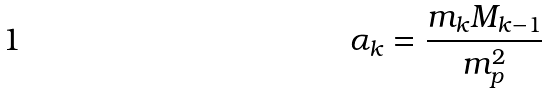<formula> <loc_0><loc_0><loc_500><loc_500>\alpha _ { k } = \frac { m _ { k } M _ { k - 1 } } { m _ { p } ^ { 2 } }</formula> 